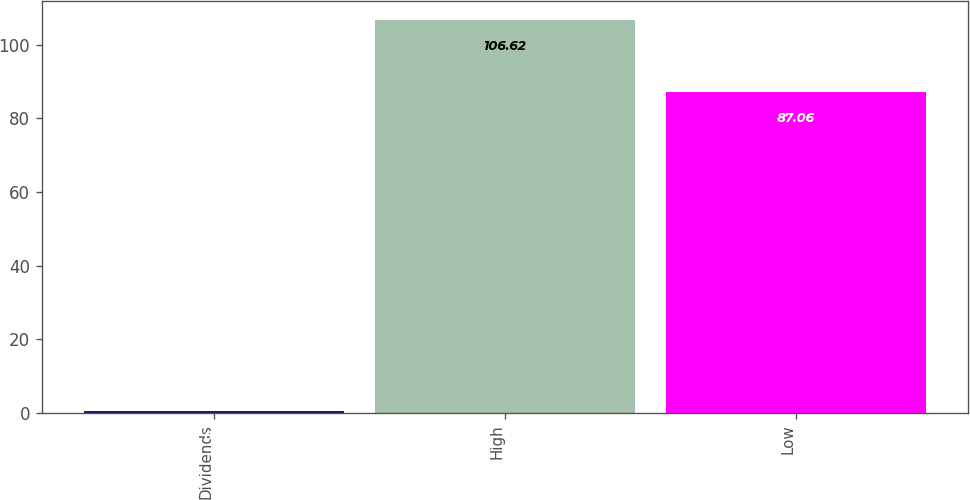<chart> <loc_0><loc_0><loc_500><loc_500><bar_chart><fcel>Dividends<fcel>High<fcel>Low<nl><fcel>0.6<fcel>106.62<fcel>87.06<nl></chart> 